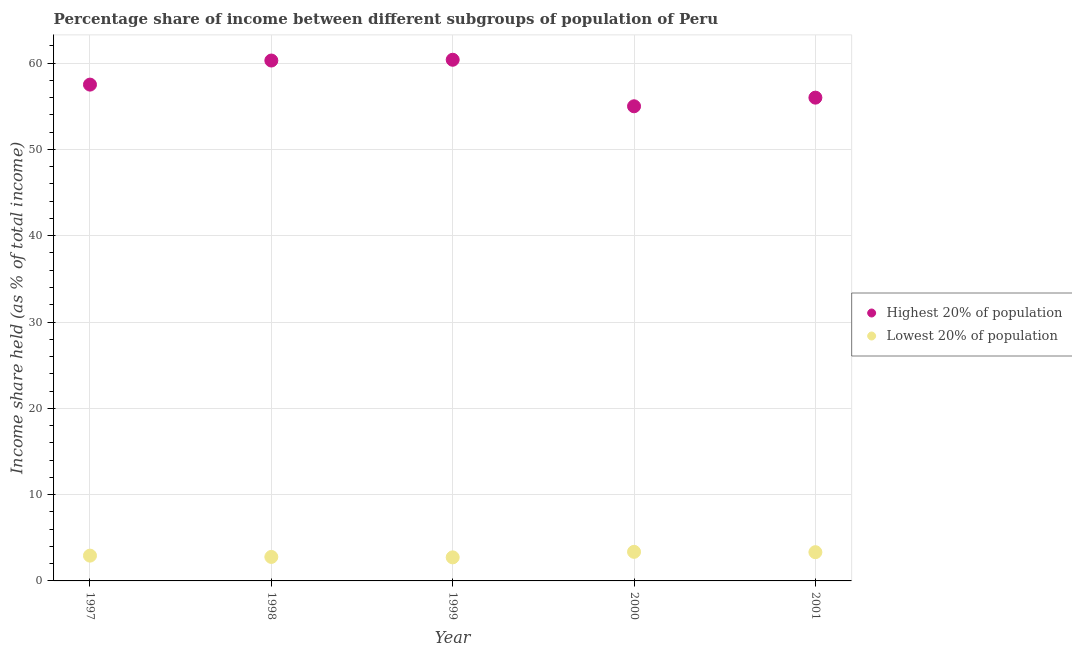How many different coloured dotlines are there?
Offer a terse response. 2. Is the number of dotlines equal to the number of legend labels?
Keep it short and to the point. Yes. What is the income share held by lowest 20% of the population in 1999?
Ensure brevity in your answer.  2.73. Across all years, what is the maximum income share held by lowest 20% of the population?
Provide a short and direct response. 3.37. Across all years, what is the minimum income share held by lowest 20% of the population?
Your response must be concise. 2.73. In which year was the income share held by highest 20% of the population minimum?
Your answer should be compact. 2000. What is the total income share held by lowest 20% of the population in the graph?
Offer a very short reply. 15.14. What is the difference between the income share held by lowest 20% of the population in 1997 and that in 2001?
Provide a succinct answer. -0.4. What is the difference between the income share held by highest 20% of the population in 1997 and the income share held by lowest 20% of the population in 1999?
Keep it short and to the point. 54.78. What is the average income share held by highest 20% of the population per year?
Offer a very short reply. 57.84. In the year 1999, what is the difference between the income share held by highest 20% of the population and income share held by lowest 20% of the population?
Your answer should be compact. 57.66. In how many years, is the income share held by highest 20% of the population greater than 14 %?
Your response must be concise. 5. What is the ratio of the income share held by highest 20% of the population in 1997 to that in 2000?
Give a very brief answer. 1.05. What is the difference between the highest and the second highest income share held by lowest 20% of the population?
Make the answer very short. 0.04. What is the difference between the highest and the lowest income share held by highest 20% of the population?
Your answer should be compact. 5.39. Is the sum of the income share held by highest 20% of the population in 1997 and 2001 greater than the maximum income share held by lowest 20% of the population across all years?
Give a very brief answer. Yes. Does the income share held by lowest 20% of the population monotonically increase over the years?
Your answer should be very brief. No. How many dotlines are there?
Offer a terse response. 2. How many years are there in the graph?
Keep it short and to the point. 5. What is the difference between two consecutive major ticks on the Y-axis?
Provide a short and direct response. 10. Does the graph contain any zero values?
Make the answer very short. No. Where does the legend appear in the graph?
Provide a succinct answer. Center right. How many legend labels are there?
Ensure brevity in your answer.  2. What is the title of the graph?
Ensure brevity in your answer.  Percentage share of income between different subgroups of population of Peru. Does "Merchandise exports" appear as one of the legend labels in the graph?
Your answer should be compact. No. What is the label or title of the X-axis?
Provide a succinct answer. Year. What is the label or title of the Y-axis?
Provide a short and direct response. Income share held (as % of total income). What is the Income share held (as % of total income) in Highest 20% of population in 1997?
Offer a very short reply. 57.51. What is the Income share held (as % of total income) of Lowest 20% of population in 1997?
Give a very brief answer. 2.93. What is the Income share held (as % of total income) in Highest 20% of population in 1998?
Provide a succinct answer. 60.3. What is the Income share held (as % of total income) of Lowest 20% of population in 1998?
Provide a succinct answer. 2.78. What is the Income share held (as % of total income) of Highest 20% of population in 1999?
Your response must be concise. 60.39. What is the Income share held (as % of total income) of Lowest 20% of population in 1999?
Offer a terse response. 2.73. What is the Income share held (as % of total income) of Highest 20% of population in 2000?
Provide a short and direct response. 55. What is the Income share held (as % of total income) of Lowest 20% of population in 2000?
Your response must be concise. 3.37. What is the Income share held (as % of total income) of Lowest 20% of population in 2001?
Make the answer very short. 3.33. Across all years, what is the maximum Income share held (as % of total income) of Highest 20% of population?
Keep it short and to the point. 60.39. Across all years, what is the maximum Income share held (as % of total income) in Lowest 20% of population?
Your answer should be compact. 3.37. Across all years, what is the minimum Income share held (as % of total income) in Highest 20% of population?
Your answer should be compact. 55. Across all years, what is the minimum Income share held (as % of total income) in Lowest 20% of population?
Give a very brief answer. 2.73. What is the total Income share held (as % of total income) in Highest 20% of population in the graph?
Offer a terse response. 289.2. What is the total Income share held (as % of total income) in Lowest 20% of population in the graph?
Keep it short and to the point. 15.14. What is the difference between the Income share held (as % of total income) of Highest 20% of population in 1997 and that in 1998?
Provide a succinct answer. -2.79. What is the difference between the Income share held (as % of total income) of Highest 20% of population in 1997 and that in 1999?
Your answer should be very brief. -2.88. What is the difference between the Income share held (as % of total income) of Highest 20% of population in 1997 and that in 2000?
Your response must be concise. 2.51. What is the difference between the Income share held (as % of total income) in Lowest 20% of population in 1997 and that in 2000?
Your answer should be compact. -0.44. What is the difference between the Income share held (as % of total income) in Highest 20% of population in 1997 and that in 2001?
Ensure brevity in your answer.  1.51. What is the difference between the Income share held (as % of total income) in Highest 20% of population in 1998 and that in 1999?
Keep it short and to the point. -0.09. What is the difference between the Income share held (as % of total income) of Lowest 20% of population in 1998 and that in 2000?
Your response must be concise. -0.59. What is the difference between the Income share held (as % of total income) in Lowest 20% of population in 1998 and that in 2001?
Offer a terse response. -0.55. What is the difference between the Income share held (as % of total income) in Highest 20% of population in 1999 and that in 2000?
Offer a terse response. 5.39. What is the difference between the Income share held (as % of total income) of Lowest 20% of population in 1999 and that in 2000?
Your response must be concise. -0.64. What is the difference between the Income share held (as % of total income) of Highest 20% of population in 1999 and that in 2001?
Your answer should be very brief. 4.39. What is the difference between the Income share held (as % of total income) of Highest 20% of population in 2000 and that in 2001?
Offer a terse response. -1. What is the difference between the Income share held (as % of total income) of Highest 20% of population in 1997 and the Income share held (as % of total income) of Lowest 20% of population in 1998?
Provide a succinct answer. 54.73. What is the difference between the Income share held (as % of total income) in Highest 20% of population in 1997 and the Income share held (as % of total income) in Lowest 20% of population in 1999?
Make the answer very short. 54.78. What is the difference between the Income share held (as % of total income) in Highest 20% of population in 1997 and the Income share held (as % of total income) in Lowest 20% of population in 2000?
Your answer should be compact. 54.14. What is the difference between the Income share held (as % of total income) in Highest 20% of population in 1997 and the Income share held (as % of total income) in Lowest 20% of population in 2001?
Provide a succinct answer. 54.18. What is the difference between the Income share held (as % of total income) of Highest 20% of population in 1998 and the Income share held (as % of total income) of Lowest 20% of population in 1999?
Provide a succinct answer. 57.57. What is the difference between the Income share held (as % of total income) in Highest 20% of population in 1998 and the Income share held (as % of total income) in Lowest 20% of population in 2000?
Your answer should be very brief. 56.93. What is the difference between the Income share held (as % of total income) of Highest 20% of population in 1998 and the Income share held (as % of total income) of Lowest 20% of population in 2001?
Make the answer very short. 56.97. What is the difference between the Income share held (as % of total income) of Highest 20% of population in 1999 and the Income share held (as % of total income) of Lowest 20% of population in 2000?
Your answer should be compact. 57.02. What is the difference between the Income share held (as % of total income) of Highest 20% of population in 1999 and the Income share held (as % of total income) of Lowest 20% of population in 2001?
Your answer should be compact. 57.06. What is the difference between the Income share held (as % of total income) of Highest 20% of population in 2000 and the Income share held (as % of total income) of Lowest 20% of population in 2001?
Provide a short and direct response. 51.67. What is the average Income share held (as % of total income) in Highest 20% of population per year?
Provide a succinct answer. 57.84. What is the average Income share held (as % of total income) in Lowest 20% of population per year?
Give a very brief answer. 3.03. In the year 1997, what is the difference between the Income share held (as % of total income) in Highest 20% of population and Income share held (as % of total income) in Lowest 20% of population?
Give a very brief answer. 54.58. In the year 1998, what is the difference between the Income share held (as % of total income) of Highest 20% of population and Income share held (as % of total income) of Lowest 20% of population?
Your answer should be very brief. 57.52. In the year 1999, what is the difference between the Income share held (as % of total income) in Highest 20% of population and Income share held (as % of total income) in Lowest 20% of population?
Offer a very short reply. 57.66. In the year 2000, what is the difference between the Income share held (as % of total income) in Highest 20% of population and Income share held (as % of total income) in Lowest 20% of population?
Offer a terse response. 51.63. In the year 2001, what is the difference between the Income share held (as % of total income) of Highest 20% of population and Income share held (as % of total income) of Lowest 20% of population?
Offer a very short reply. 52.67. What is the ratio of the Income share held (as % of total income) in Highest 20% of population in 1997 to that in 1998?
Provide a short and direct response. 0.95. What is the ratio of the Income share held (as % of total income) in Lowest 20% of population in 1997 to that in 1998?
Offer a very short reply. 1.05. What is the ratio of the Income share held (as % of total income) of Highest 20% of population in 1997 to that in 1999?
Your answer should be compact. 0.95. What is the ratio of the Income share held (as % of total income) of Lowest 20% of population in 1997 to that in 1999?
Provide a short and direct response. 1.07. What is the ratio of the Income share held (as % of total income) in Highest 20% of population in 1997 to that in 2000?
Offer a very short reply. 1.05. What is the ratio of the Income share held (as % of total income) of Lowest 20% of population in 1997 to that in 2000?
Offer a very short reply. 0.87. What is the ratio of the Income share held (as % of total income) in Lowest 20% of population in 1997 to that in 2001?
Offer a very short reply. 0.88. What is the ratio of the Income share held (as % of total income) in Lowest 20% of population in 1998 to that in 1999?
Ensure brevity in your answer.  1.02. What is the ratio of the Income share held (as % of total income) of Highest 20% of population in 1998 to that in 2000?
Offer a very short reply. 1.1. What is the ratio of the Income share held (as % of total income) in Lowest 20% of population in 1998 to that in 2000?
Your response must be concise. 0.82. What is the ratio of the Income share held (as % of total income) in Highest 20% of population in 1998 to that in 2001?
Your answer should be compact. 1.08. What is the ratio of the Income share held (as % of total income) in Lowest 20% of population in 1998 to that in 2001?
Ensure brevity in your answer.  0.83. What is the ratio of the Income share held (as % of total income) in Highest 20% of population in 1999 to that in 2000?
Offer a terse response. 1.1. What is the ratio of the Income share held (as % of total income) of Lowest 20% of population in 1999 to that in 2000?
Keep it short and to the point. 0.81. What is the ratio of the Income share held (as % of total income) in Highest 20% of population in 1999 to that in 2001?
Your answer should be very brief. 1.08. What is the ratio of the Income share held (as % of total income) of Lowest 20% of population in 1999 to that in 2001?
Your response must be concise. 0.82. What is the ratio of the Income share held (as % of total income) of Highest 20% of population in 2000 to that in 2001?
Make the answer very short. 0.98. What is the difference between the highest and the second highest Income share held (as % of total income) in Highest 20% of population?
Provide a succinct answer. 0.09. What is the difference between the highest and the second highest Income share held (as % of total income) in Lowest 20% of population?
Offer a very short reply. 0.04. What is the difference between the highest and the lowest Income share held (as % of total income) in Highest 20% of population?
Your answer should be very brief. 5.39. What is the difference between the highest and the lowest Income share held (as % of total income) in Lowest 20% of population?
Offer a terse response. 0.64. 